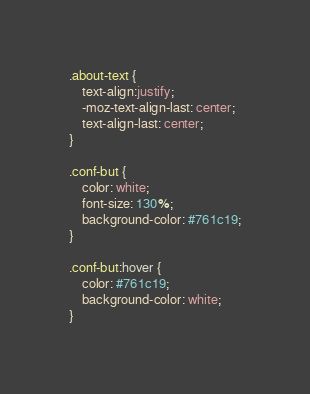<code> <loc_0><loc_0><loc_500><loc_500><_CSS_>
.about-text {
    text-align:justify;
    -moz-text-align-last: center;
    text-align-last: center;
}

.conf-but {
    color: white;
    font-size: 130%;
    background-color: #761c19;
}

.conf-but:hover {
    color: #761c19;
    background-color: white;
}</code> 